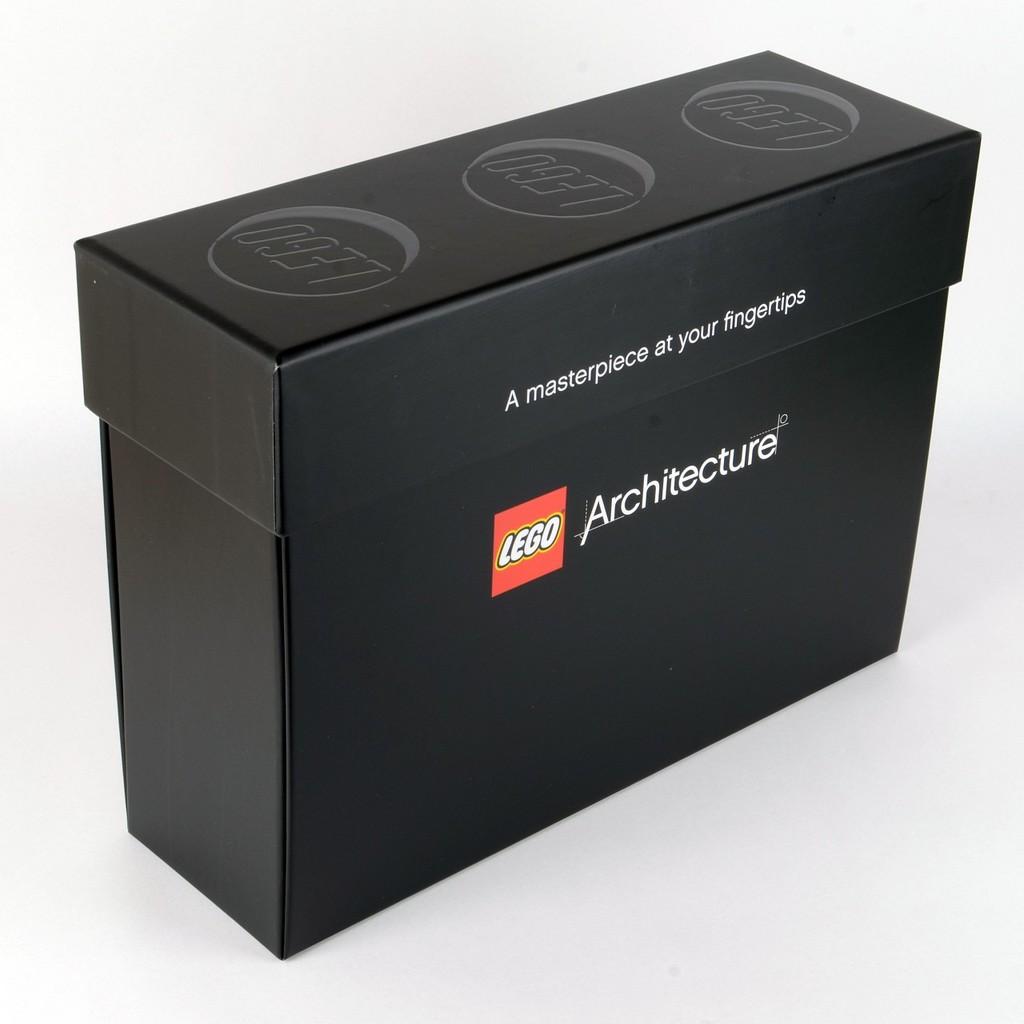What is a masterpiece at your fingertips?
Give a very brief answer. Lego architecture. What is the brand of this product?
Make the answer very short. Lego. 